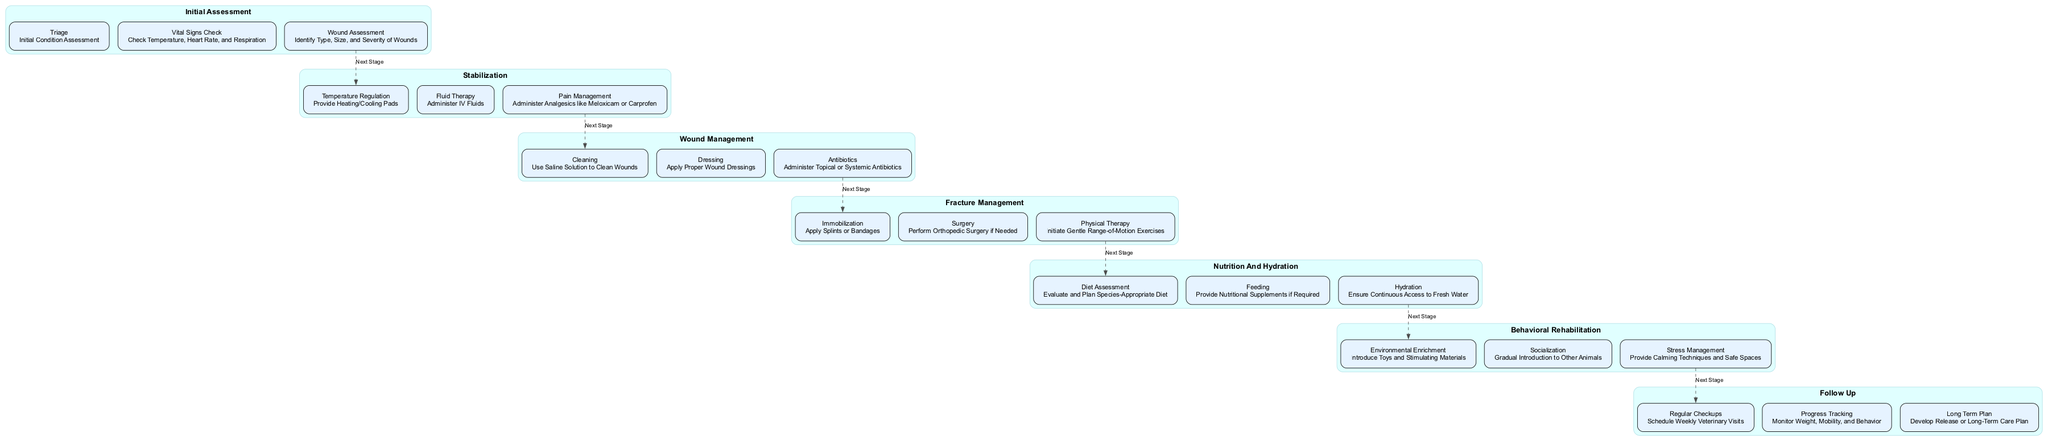What's the first step in the clinical pathway? The first step is "Initial Assessment," as indicated at the top of the diagram, which leads the process of treating injured animals.
Answer: Initial Assessment How many steps are there in the stabilization phase? The stabilization phase includes three steps: temperature regulation, fluid therapy, and pain management, which are listed in that section of the diagram.
Answer: 3 What type of therapy is initiated during fracture management? The diagram specifies that "Gentle Range-of-Motion Exercises" are part of the fracture management process, indicating the type of therapy.
Answer: Physical therapy What is the last phase before follow-up? The diagram shows that "Behavioral Rehabilitation" is the last phase before the follow-up phase, highlighting the focus on animal behavior and socialization.
Answer: Behavioral Rehabilitation What is the main focus of the nutrition and hydration phase? The main focus is on "Diet Assessment," which indicates evaluating and planning a species-appropriate diet for the injured animals.
Answer: Diet Assessment Which step involves administering analgesics? The diagram indicates that "Pain Management" in the stabilization phase involves administering analgesics such as Meloxicam or Carprofen for pain relief.
Answer: Pain Management How do you progress from wound management to fracture management? The transition from "Wound Management" to "Fracture Management" follows a dashed edge in the diagram, indicating the flow from one process to the next.
Answer: Next Stage What is emphasized in the follow-up phase regarding the animal's recovery? The follow-up phase emphasizes "Monitoring Weight, Mobility, and Behavior," indicating the importance of tracking the animal's recovery progress after treatment.
Answer: Progress Tracking What is one component of environmental enrichment? The diagram lists "Introduce Toys and Stimulating Materials" as part of environmental enrichment to aid in behavioral rehabilitation.
Answer: Toys and Stimulating Materials 